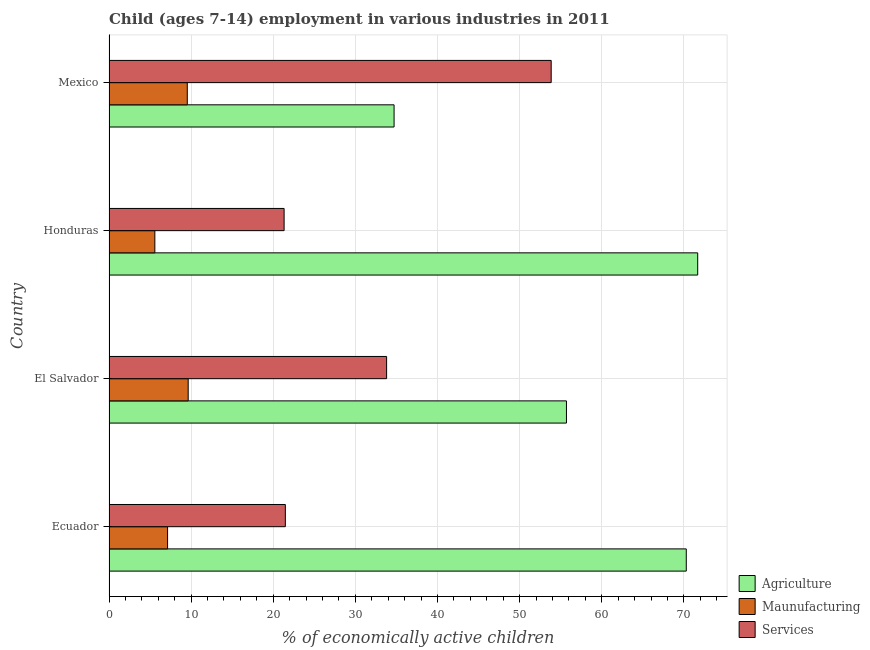How many groups of bars are there?
Make the answer very short. 4. How many bars are there on the 1st tick from the top?
Provide a succinct answer. 3. What is the label of the 3rd group of bars from the top?
Your answer should be compact. El Salvador. What is the percentage of economically active children in manufacturing in Mexico?
Provide a succinct answer. 9.53. Across all countries, what is the maximum percentage of economically active children in services?
Keep it short and to the point. 53.84. Across all countries, what is the minimum percentage of economically active children in services?
Keep it short and to the point. 21.32. In which country was the percentage of economically active children in services maximum?
Provide a succinct answer. Mexico. In which country was the percentage of economically active children in agriculture minimum?
Your answer should be compact. Mexico. What is the total percentage of economically active children in services in the graph?
Keep it short and to the point. 130.43. What is the difference between the percentage of economically active children in agriculture in Ecuador and that in Mexico?
Give a very brief answer. 35.58. What is the difference between the percentage of economically active children in manufacturing in Ecuador and the percentage of economically active children in agriculture in Mexico?
Give a very brief answer. -27.58. What is the average percentage of economically active children in agriculture per country?
Ensure brevity in your answer.  58.09. What is the difference between the percentage of economically active children in agriculture and percentage of economically active children in manufacturing in Honduras?
Ensure brevity in your answer.  66.1. In how many countries, is the percentage of economically active children in manufacturing greater than 4 %?
Your response must be concise. 4. What is the ratio of the percentage of economically active children in agriculture in Honduras to that in Mexico?
Offer a terse response. 2.06. Is the percentage of economically active children in manufacturing in El Salvador less than that in Mexico?
Ensure brevity in your answer.  No. Is the difference between the percentage of economically active children in services in Honduras and Mexico greater than the difference between the percentage of economically active children in agriculture in Honduras and Mexico?
Provide a succinct answer. No. What is the difference between the highest and the second highest percentage of economically active children in manufacturing?
Provide a short and direct response. 0.11. What is the difference between the highest and the lowest percentage of economically active children in agriculture?
Provide a short and direct response. 36.97. What does the 1st bar from the top in Mexico represents?
Offer a very short reply. Services. What does the 2nd bar from the bottom in El Salvador represents?
Your answer should be very brief. Maunufacturing. How many bars are there?
Offer a very short reply. 12. Are the values on the major ticks of X-axis written in scientific E-notation?
Make the answer very short. No. Where does the legend appear in the graph?
Offer a terse response. Bottom right. How many legend labels are there?
Give a very brief answer. 3. What is the title of the graph?
Provide a short and direct response. Child (ages 7-14) employment in various industries in 2011. Does "Central government" appear as one of the legend labels in the graph?
Your answer should be very brief. No. What is the label or title of the X-axis?
Your answer should be compact. % of economically active children. What is the % of economically active children of Agriculture in Ecuador?
Your answer should be very brief. 70.29. What is the % of economically active children of Maunufacturing in Ecuador?
Offer a very short reply. 7.13. What is the % of economically active children of Services in Ecuador?
Your response must be concise. 21.47. What is the % of economically active children in Agriculture in El Salvador?
Keep it short and to the point. 55.7. What is the % of economically active children of Maunufacturing in El Salvador?
Make the answer very short. 9.64. What is the % of economically active children in Services in El Salvador?
Offer a terse response. 33.8. What is the % of economically active children of Agriculture in Honduras?
Offer a very short reply. 71.68. What is the % of economically active children in Maunufacturing in Honduras?
Your answer should be compact. 5.58. What is the % of economically active children in Services in Honduras?
Provide a short and direct response. 21.32. What is the % of economically active children in Agriculture in Mexico?
Give a very brief answer. 34.71. What is the % of economically active children of Maunufacturing in Mexico?
Offer a terse response. 9.53. What is the % of economically active children of Services in Mexico?
Your answer should be compact. 53.84. Across all countries, what is the maximum % of economically active children in Agriculture?
Ensure brevity in your answer.  71.68. Across all countries, what is the maximum % of economically active children in Maunufacturing?
Offer a terse response. 9.64. Across all countries, what is the maximum % of economically active children of Services?
Give a very brief answer. 53.84. Across all countries, what is the minimum % of economically active children of Agriculture?
Make the answer very short. 34.71. Across all countries, what is the minimum % of economically active children of Maunufacturing?
Your answer should be compact. 5.58. Across all countries, what is the minimum % of economically active children in Services?
Provide a short and direct response. 21.32. What is the total % of economically active children in Agriculture in the graph?
Give a very brief answer. 232.38. What is the total % of economically active children in Maunufacturing in the graph?
Keep it short and to the point. 31.88. What is the total % of economically active children of Services in the graph?
Provide a succinct answer. 130.43. What is the difference between the % of economically active children in Agriculture in Ecuador and that in El Salvador?
Your answer should be compact. 14.59. What is the difference between the % of economically active children of Maunufacturing in Ecuador and that in El Salvador?
Offer a very short reply. -2.51. What is the difference between the % of economically active children of Services in Ecuador and that in El Salvador?
Offer a terse response. -12.33. What is the difference between the % of economically active children of Agriculture in Ecuador and that in Honduras?
Ensure brevity in your answer.  -1.39. What is the difference between the % of economically active children in Maunufacturing in Ecuador and that in Honduras?
Provide a short and direct response. 1.55. What is the difference between the % of economically active children of Agriculture in Ecuador and that in Mexico?
Your answer should be compact. 35.58. What is the difference between the % of economically active children of Services in Ecuador and that in Mexico?
Keep it short and to the point. -32.37. What is the difference between the % of economically active children in Agriculture in El Salvador and that in Honduras?
Your answer should be compact. -15.98. What is the difference between the % of economically active children in Maunufacturing in El Salvador and that in Honduras?
Your answer should be very brief. 4.06. What is the difference between the % of economically active children in Services in El Salvador and that in Honduras?
Keep it short and to the point. 12.48. What is the difference between the % of economically active children in Agriculture in El Salvador and that in Mexico?
Provide a short and direct response. 20.99. What is the difference between the % of economically active children in Maunufacturing in El Salvador and that in Mexico?
Provide a short and direct response. 0.11. What is the difference between the % of economically active children in Services in El Salvador and that in Mexico?
Offer a terse response. -20.04. What is the difference between the % of economically active children of Agriculture in Honduras and that in Mexico?
Provide a short and direct response. 36.97. What is the difference between the % of economically active children of Maunufacturing in Honduras and that in Mexico?
Provide a succinct answer. -3.95. What is the difference between the % of economically active children in Services in Honduras and that in Mexico?
Make the answer very short. -32.52. What is the difference between the % of economically active children of Agriculture in Ecuador and the % of economically active children of Maunufacturing in El Salvador?
Your answer should be very brief. 60.65. What is the difference between the % of economically active children in Agriculture in Ecuador and the % of economically active children in Services in El Salvador?
Give a very brief answer. 36.49. What is the difference between the % of economically active children in Maunufacturing in Ecuador and the % of economically active children in Services in El Salvador?
Keep it short and to the point. -26.67. What is the difference between the % of economically active children of Agriculture in Ecuador and the % of economically active children of Maunufacturing in Honduras?
Your response must be concise. 64.71. What is the difference between the % of economically active children of Agriculture in Ecuador and the % of economically active children of Services in Honduras?
Offer a very short reply. 48.97. What is the difference between the % of economically active children in Maunufacturing in Ecuador and the % of economically active children in Services in Honduras?
Your answer should be compact. -14.19. What is the difference between the % of economically active children of Agriculture in Ecuador and the % of economically active children of Maunufacturing in Mexico?
Provide a short and direct response. 60.76. What is the difference between the % of economically active children of Agriculture in Ecuador and the % of economically active children of Services in Mexico?
Your answer should be compact. 16.45. What is the difference between the % of economically active children of Maunufacturing in Ecuador and the % of economically active children of Services in Mexico?
Keep it short and to the point. -46.71. What is the difference between the % of economically active children in Agriculture in El Salvador and the % of economically active children in Maunufacturing in Honduras?
Provide a short and direct response. 50.12. What is the difference between the % of economically active children in Agriculture in El Salvador and the % of economically active children in Services in Honduras?
Provide a succinct answer. 34.38. What is the difference between the % of economically active children in Maunufacturing in El Salvador and the % of economically active children in Services in Honduras?
Provide a short and direct response. -11.68. What is the difference between the % of economically active children of Agriculture in El Salvador and the % of economically active children of Maunufacturing in Mexico?
Ensure brevity in your answer.  46.17. What is the difference between the % of economically active children of Agriculture in El Salvador and the % of economically active children of Services in Mexico?
Your response must be concise. 1.86. What is the difference between the % of economically active children of Maunufacturing in El Salvador and the % of economically active children of Services in Mexico?
Make the answer very short. -44.2. What is the difference between the % of economically active children in Agriculture in Honduras and the % of economically active children in Maunufacturing in Mexico?
Provide a succinct answer. 62.15. What is the difference between the % of economically active children in Agriculture in Honduras and the % of economically active children in Services in Mexico?
Provide a short and direct response. 17.84. What is the difference between the % of economically active children of Maunufacturing in Honduras and the % of economically active children of Services in Mexico?
Offer a terse response. -48.26. What is the average % of economically active children in Agriculture per country?
Keep it short and to the point. 58.09. What is the average % of economically active children in Maunufacturing per country?
Make the answer very short. 7.97. What is the average % of economically active children in Services per country?
Your answer should be very brief. 32.61. What is the difference between the % of economically active children in Agriculture and % of economically active children in Maunufacturing in Ecuador?
Provide a short and direct response. 63.16. What is the difference between the % of economically active children of Agriculture and % of economically active children of Services in Ecuador?
Offer a terse response. 48.82. What is the difference between the % of economically active children in Maunufacturing and % of economically active children in Services in Ecuador?
Offer a very short reply. -14.34. What is the difference between the % of economically active children in Agriculture and % of economically active children in Maunufacturing in El Salvador?
Your response must be concise. 46.06. What is the difference between the % of economically active children of Agriculture and % of economically active children of Services in El Salvador?
Offer a terse response. 21.9. What is the difference between the % of economically active children in Maunufacturing and % of economically active children in Services in El Salvador?
Your response must be concise. -24.16. What is the difference between the % of economically active children in Agriculture and % of economically active children in Maunufacturing in Honduras?
Provide a succinct answer. 66.1. What is the difference between the % of economically active children of Agriculture and % of economically active children of Services in Honduras?
Your answer should be compact. 50.36. What is the difference between the % of economically active children in Maunufacturing and % of economically active children in Services in Honduras?
Provide a succinct answer. -15.74. What is the difference between the % of economically active children in Agriculture and % of economically active children in Maunufacturing in Mexico?
Your answer should be very brief. 25.18. What is the difference between the % of economically active children of Agriculture and % of economically active children of Services in Mexico?
Make the answer very short. -19.13. What is the difference between the % of economically active children in Maunufacturing and % of economically active children in Services in Mexico?
Give a very brief answer. -44.31. What is the ratio of the % of economically active children of Agriculture in Ecuador to that in El Salvador?
Give a very brief answer. 1.26. What is the ratio of the % of economically active children of Maunufacturing in Ecuador to that in El Salvador?
Your answer should be very brief. 0.74. What is the ratio of the % of economically active children of Services in Ecuador to that in El Salvador?
Make the answer very short. 0.64. What is the ratio of the % of economically active children of Agriculture in Ecuador to that in Honduras?
Give a very brief answer. 0.98. What is the ratio of the % of economically active children of Maunufacturing in Ecuador to that in Honduras?
Your answer should be very brief. 1.28. What is the ratio of the % of economically active children of Agriculture in Ecuador to that in Mexico?
Your answer should be very brief. 2.03. What is the ratio of the % of economically active children of Maunufacturing in Ecuador to that in Mexico?
Your response must be concise. 0.75. What is the ratio of the % of economically active children of Services in Ecuador to that in Mexico?
Give a very brief answer. 0.4. What is the ratio of the % of economically active children in Agriculture in El Salvador to that in Honduras?
Provide a succinct answer. 0.78. What is the ratio of the % of economically active children in Maunufacturing in El Salvador to that in Honduras?
Make the answer very short. 1.73. What is the ratio of the % of economically active children in Services in El Salvador to that in Honduras?
Provide a short and direct response. 1.59. What is the ratio of the % of economically active children of Agriculture in El Salvador to that in Mexico?
Give a very brief answer. 1.6. What is the ratio of the % of economically active children in Maunufacturing in El Salvador to that in Mexico?
Provide a succinct answer. 1.01. What is the ratio of the % of economically active children of Services in El Salvador to that in Mexico?
Your answer should be compact. 0.63. What is the ratio of the % of economically active children in Agriculture in Honduras to that in Mexico?
Your answer should be very brief. 2.07. What is the ratio of the % of economically active children in Maunufacturing in Honduras to that in Mexico?
Offer a terse response. 0.59. What is the ratio of the % of economically active children in Services in Honduras to that in Mexico?
Your response must be concise. 0.4. What is the difference between the highest and the second highest % of economically active children in Agriculture?
Provide a succinct answer. 1.39. What is the difference between the highest and the second highest % of economically active children in Maunufacturing?
Provide a short and direct response. 0.11. What is the difference between the highest and the second highest % of economically active children in Services?
Give a very brief answer. 20.04. What is the difference between the highest and the lowest % of economically active children of Agriculture?
Your answer should be very brief. 36.97. What is the difference between the highest and the lowest % of economically active children of Maunufacturing?
Your answer should be compact. 4.06. What is the difference between the highest and the lowest % of economically active children in Services?
Your response must be concise. 32.52. 